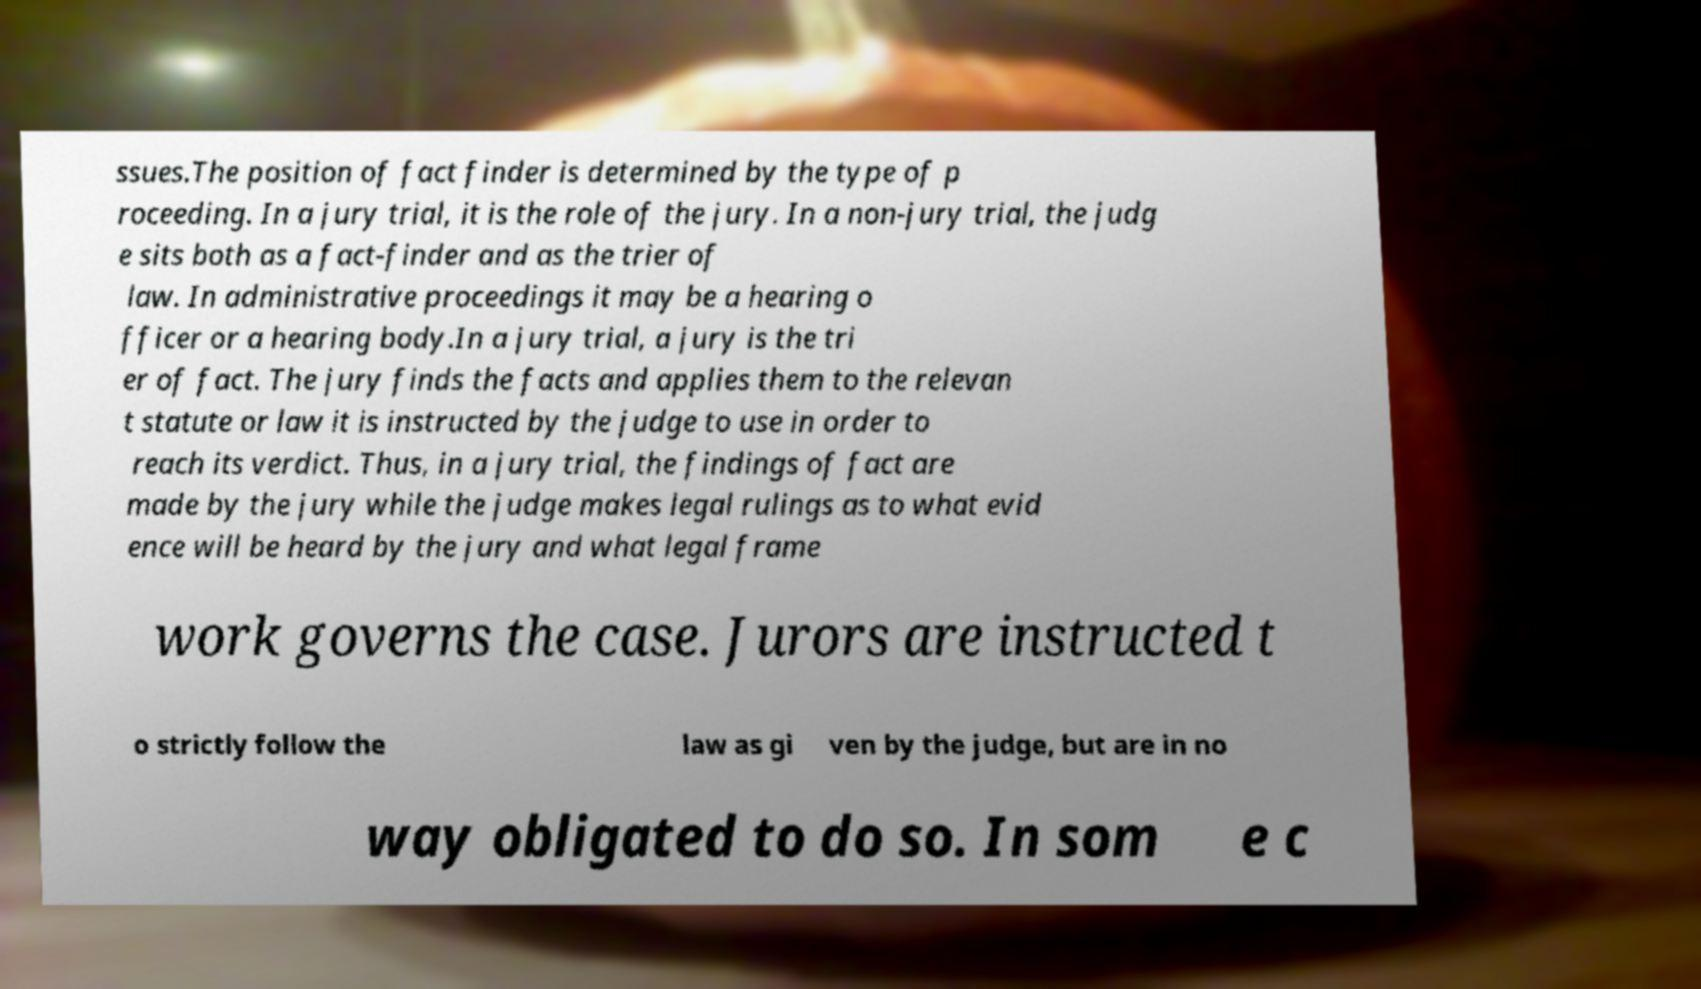Can you read and provide the text displayed in the image?This photo seems to have some interesting text. Can you extract and type it out for me? ssues.The position of fact finder is determined by the type of p roceeding. In a jury trial, it is the role of the jury. In a non-jury trial, the judg e sits both as a fact-finder and as the trier of law. In administrative proceedings it may be a hearing o fficer or a hearing body.In a jury trial, a jury is the tri er of fact. The jury finds the facts and applies them to the relevan t statute or law it is instructed by the judge to use in order to reach its verdict. Thus, in a jury trial, the findings of fact are made by the jury while the judge makes legal rulings as to what evid ence will be heard by the jury and what legal frame work governs the case. Jurors are instructed t o strictly follow the law as gi ven by the judge, but are in no way obligated to do so. In som e c 